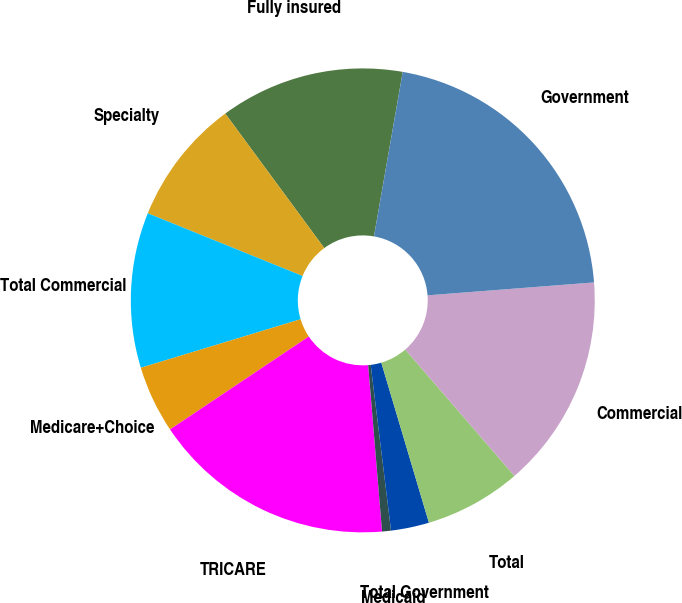<chart> <loc_0><loc_0><loc_500><loc_500><pie_chart><fcel>Fully insured<fcel>Specialty<fcel>Total Commercial<fcel>Medicare+Choice<fcel>TRICARE<fcel>Medicaid<fcel>Total Government<fcel>Total<fcel>Commercial<fcel>Government<nl><fcel>12.86%<fcel>8.78%<fcel>10.82%<fcel>4.7%<fcel>16.94%<fcel>0.62%<fcel>2.66%<fcel>6.74%<fcel>14.9%<fcel>21.02%<nl></chart> 